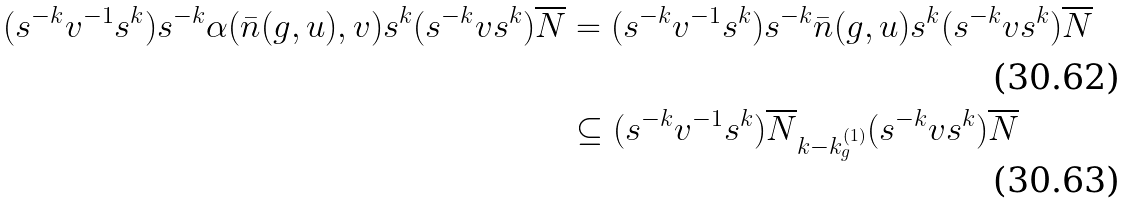<formula> <loc_0><loc_0><loc_500><loc_500>( s ^ { - k } v ^ { - 1 } s ^ { k } ) s ^ { - k } \alpha ( \bar { n } ( g , u ) , v ) s ^ { k } ( s ^ { - k } v s ^ { k } ) \overline { N } & = ( s ^ { - k } v ^ { - 1 } s ^ { k } ) s ^ { - k } \bar { n } ( g , u ) s ^ { k } ( s ^ { - k } v s ^ { k } ) \overline { N } \\ & \subseteq ( s ^ { - k } v ^ { - 1 } s ^ { k } ) \overline { N } _ { k - k _ { g } ^ { ( 1 ) } } ( s ^ { - k } v s ^ { k } ) \overline { N }</formula> 